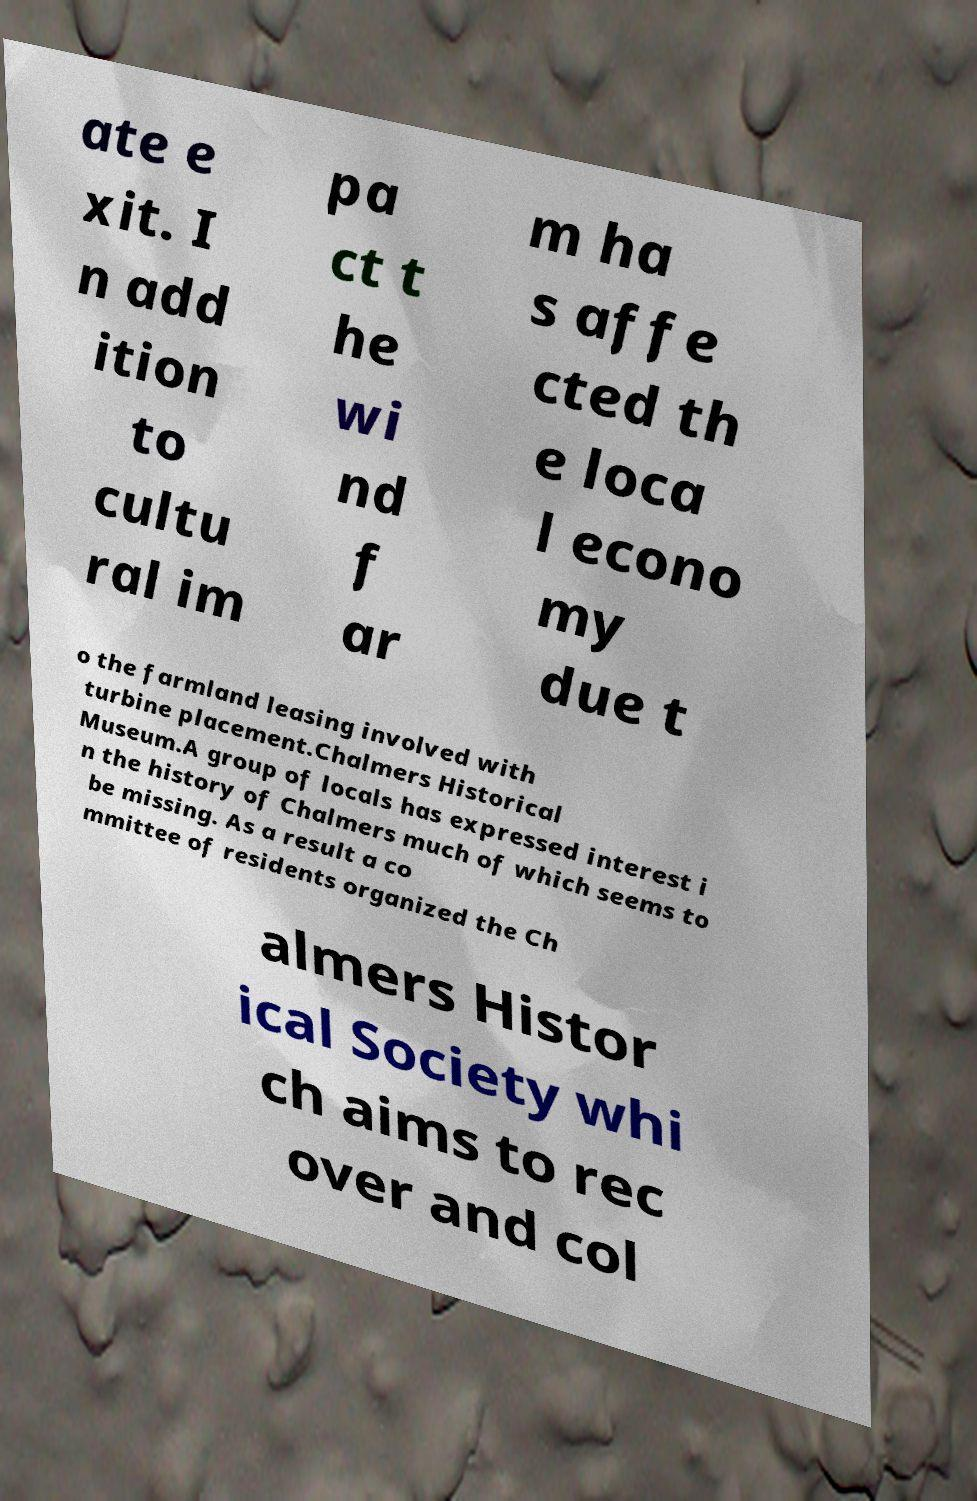Can you read and provide the text displayed in the image?This photo seems to have some interesting text. Can you extract and type it out for me? ate e xit. I n add ition to cultu ral im pa ct t he wi nd f ar m ha s affe cted th e loca l econo my due t o the farmland leasing involved with turbine placement.Chalmers Historical Museum.A group of locals has expressed interest i n the history of Chalmers much of which seems to be missing. As a result a co mmittee of residents organized the Ch almers Histor ical Society whi ch aims to rec over and col 